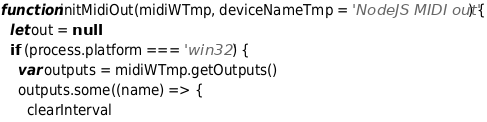<code> <loc_0><loc_0><loc_500><loc_500><_JavaScript_>function initMidiOut(midiWTmp, deviceNameTmp = 'NodeJS MIDI out') {
  let out = null
  if (process.platform === 'win32') {
    var outputs = midiWTmp.getOutputs()
    outputs.some((name) => {
      clearInterval</code> 